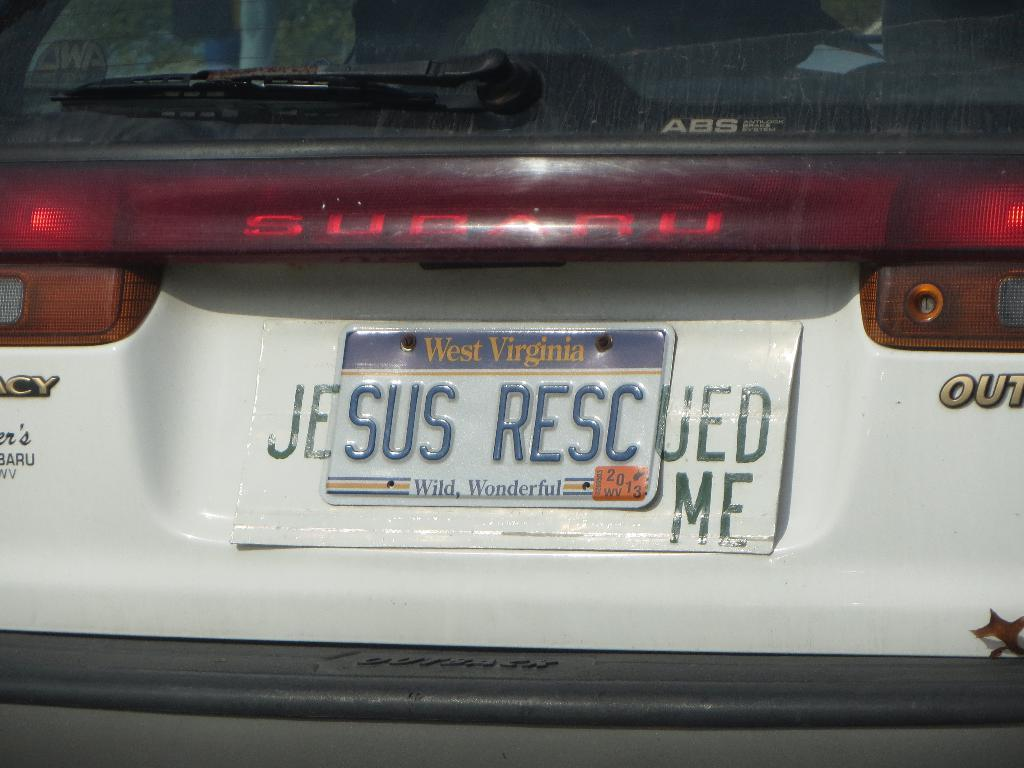<image>
Render a clear and concise summary of the photo. A Subaru has a license plate from West Virginia on it. 